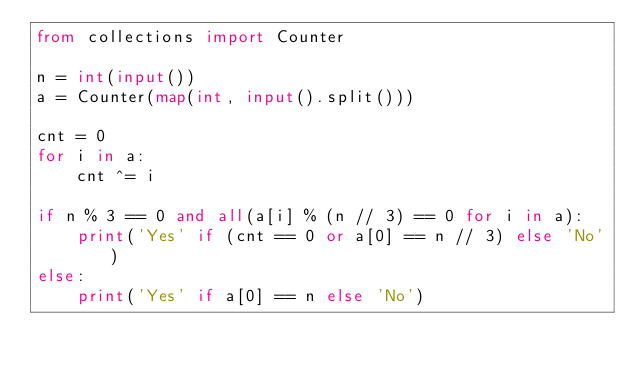Convert code to text. <code><loc_0><loc_0><loc_500><loc_500><_Python_>from collections import Counter

n = int(input())
a = Counter(map(int, input().split()))

cnt = 0
for i in a:
    cnt ^= i

if n % 3 == 0 and all(a[i] % (n // 3) == 0 for i in a):
    print('Yes' if (cnt == 0 or a[0] == n // 3) else 'No')
else:
    print('Yes' if a[0] == n else 'No')
</code> 